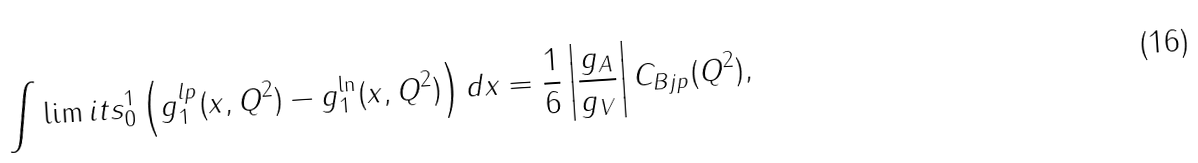<formula> <loc_0><loc_0><loc_500><loc_500>\int \lim i t s _ { 0 } ^ { 1 } \left ( g ^ { l p } _ { 1 } ( x , Q ^ { 2 } ) - g ^ { \ln } _ { 1 } ( x , Q ^ { 2 } ) \right ) d x = \frac { 1 } { 6 } \left | \frac { g _ { A } } { g _ { V } } \right | C _ { B j p } ( Q ^ { 2 } ) ,</formula> 